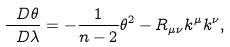<formula> <loc_0><loc_0><loc_500><loc_500>\frac { \ D \theta } { \ D \lambda } = - \frac { 1 } { n - 2 } \theta ^ { 2 } - R _ { \mu \nu } k ^ { \mu } k ^ { \nu } ,</formula> 